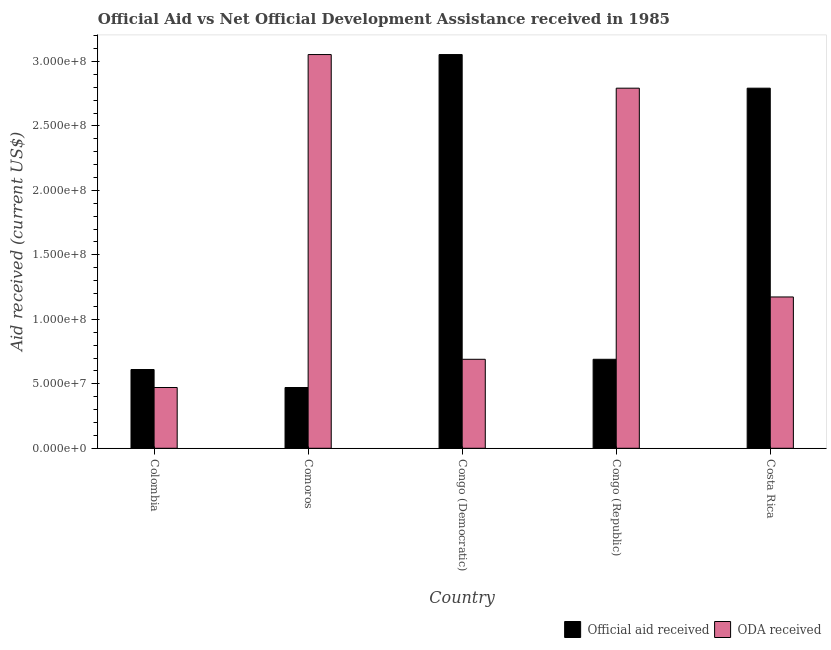How many different coloured bars are there?
Offer a terse response. 2. Are the number of bars per tick equal to the number of legend labels?
Ensure brevity in your answer.  Yes. How many bars are there on the 3rd tick from the left?
Your response must be concise. 2. What is the label of the 4th group of bars from the left?
Give a very brief answer. Congo (Republic). What is the official aid received in Congo (Democratic)?
Offer a very short reply. 3.05e+08. Across all countries, what is the maximum oda received?
Give a very brief answer. 3.05e+08. Across all countries, what is the minimum oda received?
Give a very brief answer. 4.71e+07. In which country was the official aid received maximum?
Your response must be concise. Congo (Democratic). In which country was the official aid received minimum?
Keep it short and to the point. Comoros. What is the total oda received in the graph?
Your answer should be very brief. 8.18e+08. What is the difference between the oda received in Colombia and that in Costa Rica?
Your response must be concise. -7.02e+07. What is the difference between the official aid received in Colombia and the oda received in Congo (Democratic)?
Provide a short and direct response. -7.94e+06. What is the average official aid received per country?
Ensure brevity in your answer.  1.52e+08. What is the difference between the official aid received and oda received in Congo (Democratic)?
Keep it short and to the point. 2.36e+08. What is the ratio of the official aid received in Congo (Democratic) to that in Costa Rica?
Make the answer very short. 1.09. Is the official aid received in Congo (Democratic) less than that in Costa Rica?
Your response must be concise. No. What is the difference between the highest and the second highest oda received?
Provide a succinct answer. 2.61e+07. What is the difference between the highest and the lowest oda received?
Provide a short and direct response. 2.58e+08. What does the 1st bar from the left in Colombia represents?
Offer a very short reply. Official aid received. What does the 1st bar from the right in Colombia represents?
Keep it short and to the point. ODA received. What is the difference between two consecutive major ticks on the Y-axis?
Your answer should be very brief. 5.00e+07. Where does the legend appear in the graph?
Your answer should be compact. Bottom right. How many legend labels are there?
Provide a short and direct response. 2. What is the title of the graph?
Keep it short and to the point. Official Aid vs Net Official Development Assistance received in 1985 . What is the label or title of the Y-axis?
Make the answer very short. Aid received (current US$). What is the Aid received (current US$) in Official aid received in Colombia?
Provide a short and direct response. 6.11e+07. What is the Aid received (current US$) in ODA received in Colombia?
Give a very brief answer. 4.71e+07. What is the Aid received (current US$) in Official aid received in Comoros?
Offer a terse response. 4.71e+07. What is the Aid received (current US$) in ODA received in Comoros?
Provide a short and direct response. 3.05e+08. What is the Aid received (current US$) of Official aid received in Congo (Democratic)?
Provide a short and direct response. 3.05e+08. What is the Aid received (current US$) of ODA received in Congo (Democratic)?
Offer a very short reply. 6.90e+07. What is the Aid received (current US$) in Official aid received in Congo (Republic)?
Make the answer very short. 6.90e+07. What is the Aid received (current US$) in ODA received in Congo (Republic)?
Provide a succinct answer. 2.79e+08. What is the Aid received (current US$) in Official aid received in Costa Rica?
Give a very brief answer. 2.79e+08. What is the Aid received (current US$) of ODA received in Costa Rica?
Give a very brief answer. 1.17e+08. Across all countries, what is the maximum Aid received (current US$) in Official aid received?
Give a very brief answer. 3.05e+08. Across all countries, what is the maximum Aid received (current US$) of ODA received?
Give a very brief answer. 3.05e+08. Across all countries, what is the minimum Aid received (current US$) of Official aid received?
Your response must be concise. 4.71e+07. Across all countries, what is the minimum Aid received (current US$) in ODA received?
Offer a terse response. 4.71e+07. What is the total Aid received (current US$) of Official aid received in the graph?
Provide a short and direct response. 7.62e+08. What is the total Aid received (current US$) in ODA received in the graph?
Provide a short and direct response. 8.18e+08. What is the difference between the Aid received (current US$) in Official aid received in Colombia and that in Comoros?
Ensure brevity in your answer.  1.40e+07. What is the difference between the Aid received (current US$) of ODA received in Colombia and that in Comoros?
Offer a very short reply. -2.58e+08. What is the difference between the Aid received (current US$) of Official aid received in Colombia and that in Congo (Democratic)?
Ensure brevity in your answer.  -2.44e+08. What is the difference between the Aid received (current US$) in ODA received in Colombia and that in Congo (Democratic)?
Keep it short and to the point. -2.19e+07. What is the difference between the Aid received (current US$) in Official aid received in Colombia and that in Congo (Republic)?
Your answer should be very brief. -7.94e+06. What is the difference between the Aid received (current US$) in ODA received in Colombia and that in Congo (Republic)?
Provide a short and direct response. -2.32e+08. What is the difference between the Aid received (current US$) of Official aid received in Colombia and that in Costa Rica?
Your answer should be compact. -2.18e+08. What is the difference between the Aid received (current US$) in ODA received in Colombia and that in Costa Rica?
Provide a short and direct response. -7.02e+07. What is the difference between the Aid received (current US$) of Official aid received in Comoros and that in Congo (Democratic)?
Keep it short and to the point. -2.58e+08. What is the difference between the Aid received (current US$) of ODA received in Comoros and that in Congo (Democratic)?
Provide a succinct answer. 2.36e+08. What is the difference between the Aid received (current US$) in Official aid received in Comoros and that in Congo (Republic)?
Offer a very short reply. -2.19e+07. What is the difference between the Aid received (current US$) of ODA received in Comoros and that in Congo (Republic)?
Your answer should be compact. 2.61e+07. What is the difference between the Aid received (current US$) in Official aid received in Comoros and that in Costa Rica?
Your answer should be compact. -2.32e+08. What is the difference between the Aid received (current US$) of ODA received in Comoros and that in Costa Rica?
Your answer should be very brief. 1.88e+08. What is the difference between the Aid received (current US$) in Official aid received in Congo (Democratic) and that in Congo (Republic)?
Make the answer very short. 2.36e+08. What is the difference between the Aid received (current US$) of ODA received in Congo (Democratic) and that in Congo (Republic)?
Your answer should be compact. -2.10e+08. What is the difference between the Aid received (current US$) of Official aid received in Congo (Democratic) and that in Costa Rica?
Keep it short and to the point. 2.61e+07. What is the difference between the Aid received (current US$) of ODA received in Congo (Democratic) and that in Costa Rica?
Offer a terse response. -4.83e+07. What is the difference between the Aid received (current US$) in Official aid received in Congo (Republic) and that in Costa Rica?
Give a very brief answer. -2.10e+08. What is the difference between the Aid received (current US$) in ODA received in Congo (Republic) and that in Costa Rica?
Offer a very short reply. 1.62e+08. What is the difference between the Aid received (current US$) of Official aid received in Colombia and the Aid received (current US$) of ODA received in Comoros?
Your response must be concise. -2.44e+08. What is the difference between the Aid received (current US$) in Official aid received in Colombia and the Aid received (current US$) in ODA received in Congo (Democratic)?
Your response must be concise. -7.94e+06. What is the difference between the Aid received (current US$) of Official aid received in Colombia and the Aid received (current US$) of ODA received in Congo (Republic)?
Keep it short and to the point. -2.18e+08. What is the difference between the Aid received (current US$) in Official aid received in Colombia and the Aid received (current US$) in ODA received in Costa Rica?
Your answer should be compact. -5.63e+07. What is the difference between the Aid received (current US$) in Official aid received in Comoros and the Aid received (current US$) in ODA received in Congo (Democratic)?
Your answer should be very brief. -2.19e+07. What is the difference between the Aid received (current US$) of Official aid received in Comoros and the Aid received (current US$) of ODA received in Congo (Republic)?
Provide a succinct answer. -2.32e+08. What is the difference between the Aid received (current US$) of Official aid received in Comoros and the Aid received (current US$) of ODA received in Costa Rica?
Provide a succinct answer. -7.02e+07. What is the difference between the Aid received (current US$) of Official aid received in Congo (Democratic) and the Aid received (current US$) of ODA received in Congo (Republic)?
Your answer should be compact. 2.61e+07. What is the difference between the Aid received (current US$) in Official aid received in Congo (Democratic) and the Aid received (current US$) in ODA received in Costa Rica?
Keep it short and to the point. 1.88e+08. What is the difference between the Aid received (current US$) of Official aid received in Congo (Republic) and the Aid received (current US$) of ODA received in Costa Rica?
Keep it short and to the point. -4.83e+07. What is the average Aid received (current US$) in Official aid received per country?
Provide a short and direct response. 1.52e+08. What is the average Aid received (current US$) of ODA received per country?
Offer a terse response. 1.64e+08. What is the difference between the Aid received (current US$) of Official aid received and Aid received (current US$) of ODA received in Colombia?
Keep it short and to the point. 1.40e+07. What is the difference between the Aid received (current US$) of Official aid received and Aid received (current US$) of ODA received in Comoros?
Keep it short and to the point. -2.58e+08. What is the difference between the Aid received (current US$) in Official aid received and Aid received (current US$) in ODA received in Congo (Democratic)?
Ensure brevity in your answer.  2.36e+08. What is the difference between the Aid received (current US$) of Official aid received and Aid received (current US$) of ODA received in Congo (Republic)?
Your response must be concise. -2.10e+08. What is the difference between the Aid received (current US$) in Official aid received and Aid received (current US$) in ODA received in Costa Rica?
Keep it short and to the point. 1.62e+08. What is the ratio of the Aid received (current US$) in Official aid received in Colombia to that in Comoros?
Offer a very short reply. 1.3. What is the ratio of the Aid received (current US$) in ODA received in Colombia to that in Comoros?
Provide a succinct answer. 0.15. What is the ratio of the Aid received (current US$) in ODA received in Colombia to that in Congo (Democratic)?
Give a very brief answer. 0.68. What is the ratio of the Aid received (current US$) in Official aid received in Colombia to that in Congo (Republic)?
Offer a very short reply. 0.89. What is the ratio of the Aid received (current US$) of ODA received in Colombia to that in Congo (Republic)?
Provide a succinct answer. 0.17. What is the ratio of the Aid received (current US$) of Official aid received in Colombia to that in Costa Rica?
Make the answer very short. 0.22. What is the ratio of the Aid received (current US$) in ODA received in Colombia to that in Costa Rica?
Ensure brevity in your answer.  0.4. What is the ratio of the Aid received (current US$) in Official aid received in Comoros to that in Congo (Democratic)?
Your answer should be very brief. 0.15. What is the ratio of the Aid received (current US$) in ODA received in Comoros to that in Congo (Democratic)?
Provide a succinct answer. 4.42. What is the ratio of the Aid received (current US$) of Official aid received in Comoros to that in Congo (Republic)?
Offer a very short reply. 0.68. What is the ratio of the Aid received (current US$) in ODA received in Comoros to that in Congo (Republic)?
Make the answer very short. 1.09. What is the ratio of the Aid received (current US$) of Official aid received in Comoros to that in Costa Rica?
Your answer should be very brief. 0.17. What is the ratio of the Aid received (current US$) of ODA received in Comoros to that in Costa Rica?
Your response must be concise. 2.6. What is the ratio of the Aid received (current US$) of Official aid received in Congo (Democratic) to that in Congo (Republic)?
Your answer should be very brief. 4.42. What is the ratio of the Aid received (current US$) of ODA received in Congo (Democratic) to that in Congo (Republic)?
Make the answer very short. 0.25. What is the ratio of the Aid received (current US$) in Official aid received in Congo (Democratic) to that in Costa Rica?
Provide a short and direct response. 1.09. What is the ratio of the Aid received (current US$) in ODA received in Congo (Democratic) to that in Costa Rica?
Ensure brevity in your answer.  0.59. What is the ratio of the Aid received (current US$) in Official aid received in Congo (Republic) to that in Costa Rica?
Your answer should be very brief. 0.25. What is the ratio of the Aid received (current US$) in ODA received in Congo (Republic) to that in Costa Rica?
Keep it short and to the point. 2.38. What is the difference between the highest and the second highest Aid received (current US$) of Official aid received?
Provide a succinct answer. 2.61e+07. What is the difference between the highest and the second highest Aid received (current US$) in ODA received?
Provide a succinct answer. 2.61e+07. What is the difference between the highest and the lowest Aid received (current US$) of Official aid received?
Offer a very short reply. 2.58e+08. What is the difference between the highest and the lowest Aid received (current US$) in ODA received?
Offer a very short reply. 2.58e+08. 